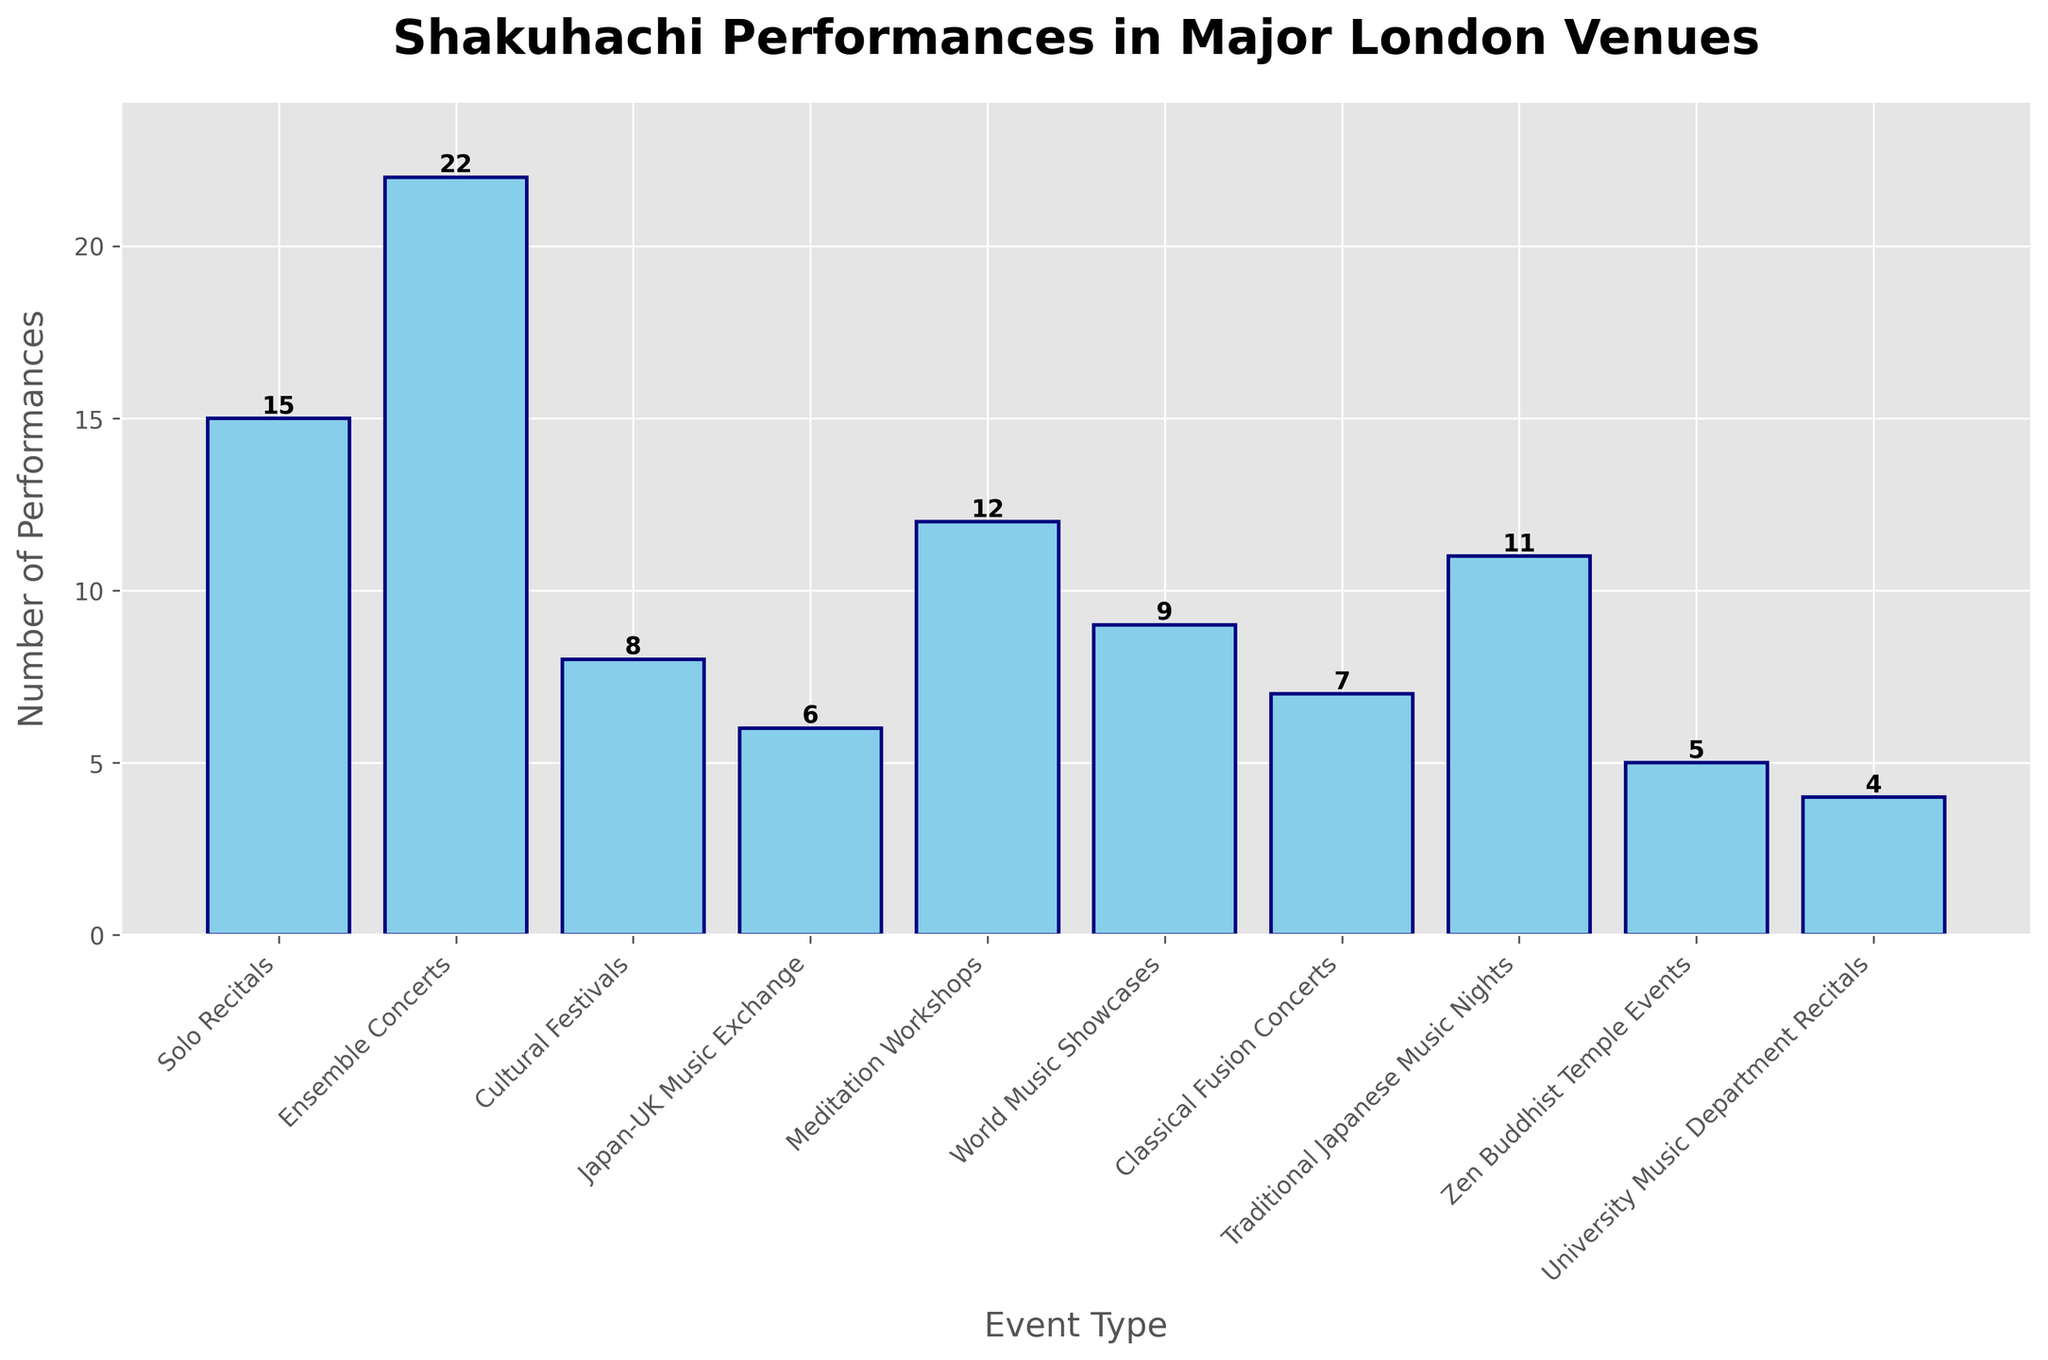What is the total number of Shakuhachi performances across all event types? Sum the number of performances for each event type: 15 (Solo Recitals) + 22 (Ensemble Concerts) + 8 (Cultural Festivals) + 6 (Japan-UK Music Exchange) + 12 (Meditation Workshops) + 9 (World Music Showcases) + 7 (Classical Fusion Concerts) + 11 (Traditional Japanese Music Nights) + 5 (Zen Buddhist Temple Events) + 4 (University Music Department Recitals) = 99
Answer: 99 Which event type has the highest number of performances? Compare the number of performances for each event type. The highest value is 22, which corresponds to Ensemble Concerts.
Answer: Ensemble Concerts What is the difference in the number of performances between Ensemble Concerts and Meditation Workshops? The number of performances for Ensemble Concerts is 22, and for Meditation Workshops is 12. The difference is 22 - 12 = 10
Answer: 10 How many more performances are there in Solo Recitals compared to Zen Buddhist Temple Events? The number of performances for Solo Recitals is 15, and for Zen Buddhist Temple Events is 5. The difference is 15 - 5 = 10
Answer: 10 What is the average number of performances per event type? Divide the total number of performances (99) by the number of event types (10). The average is 99 / 10 = 9.9
Answer: 9.9 How many event types have more than 10 performances? Identify and count the event types where the number of performances is greater than 10. These include: Ensemble Concerts (22), Solo Recitals (15), and Meditation Workshops (12). There are 3 such event types.
Answer: 3 What is the median number of Shakuhachi performances across all event types? Arrange the number of performances in ascending order: 4, 5, 6, 7, 8, 9, 11, 12, 15, 22. The median of 10 numbers is the average of the 5th and 6th values (8 and 9). The median is (8 + 9) / 2 = 8.5
Answer: 8.5 